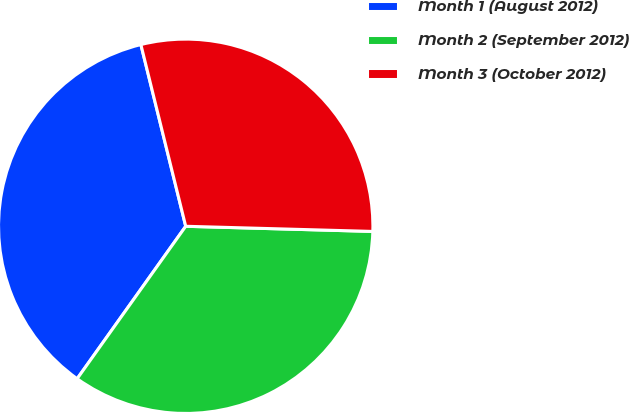Convert chart to OTSL. <chart><loc_0><loc_0><loc_500><loc_500><pie_chart><fcel>Month 1 (August 2012)<fcel>Month 2 (September 2012)<fcel>Month 3 (October 2012)<nl><fcel>36.3%<fcel>34.41%<fcel>29.29%<nl></chart> 